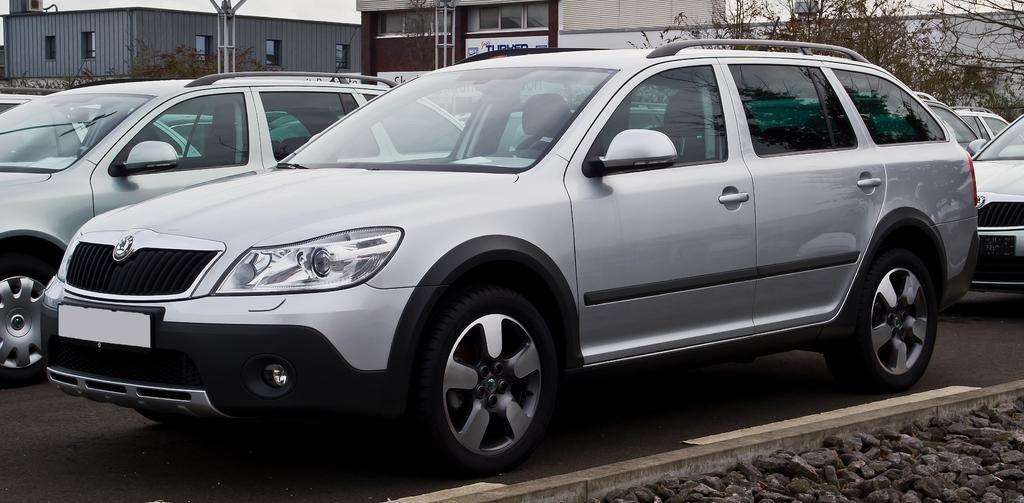Please provide a concise description of this image. In this image we can see there are vehicles on the road. And there are stones. And at the back there are buildings, trees and pole. 